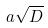<formula> <loc_0><loc_0><loc_500><loc_500>a \sqrt { D }</formula> 